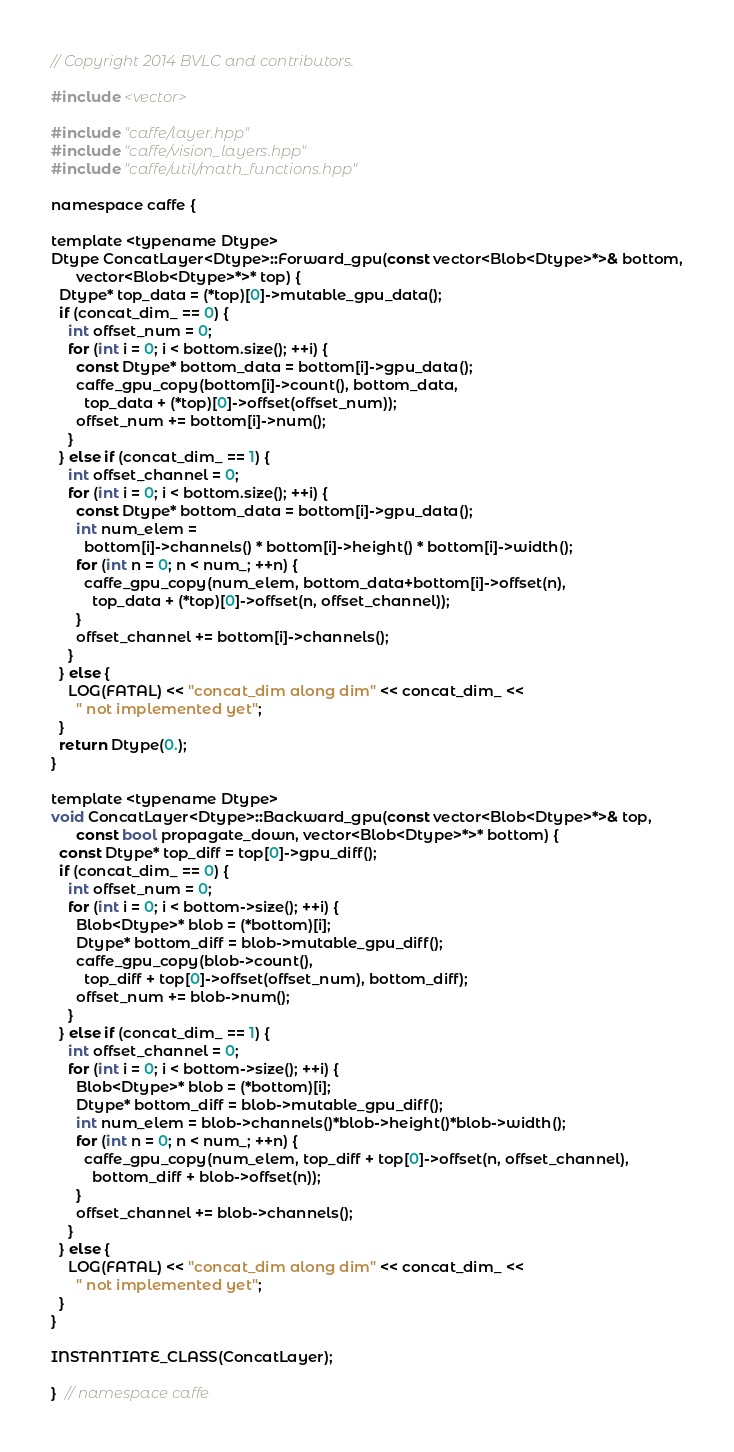Convert code to text. <code><loc_0><loc_0><loc_500><loc_500><_Cuda_>// Copyright 2014 BVLC and contributors.

#include <vector>

#include "caffe/layer.hpp"
#include "caffe/vision_layers.hpp"
#include "caffe/util/math_functions.hpp"

namespace caffe {

template <typename Dtype>
Dtype ConcatLayer<Dtype>::Forward_gpu(const vector<Blob<Dtype>*>& bottom,
      vector<Blob<Dtype>*>* top) {
  Dtype* top_data = (*top)[0]->mutable_gpu_data();
  if (concat_dim_ == 0) {
    int offset_num = 0;
    for (int i = 0; i < bottom.size(); ++i) {
      const Dtype* bottom_data = bottom[i]->gpu_data();
      caffe_gpu_copy(bottom[i]->count(), bottom_data,
        top_data + (*top)[0]->offset(offset_num));
      offset_num += bottom[i]->num();
    }
  } else if (concat_dim_ == 1) {
    int offset_channel = 0;
    for (int i = 0; i < bottom.size(); ++i) {
      const Dtype* bottom_data = bottom[i]->gpu_data();
      int num_elem =
        bottom[i]->channels() * bottom[i]->height() * bottom[i]->width();
      for (int n = 0; n < num_; ++n) {
        caffe_gpu_copy(num_elem, bottom_data+bottom[i]->offset(n),
          top_data + (*top)[0]->offset(n, offset_channel));
      }
      offset_channel += bottom[i]->channels();
    }
  } else {
    LOG(FATAL) << "concat_dim along dim" << concat_dim_ <<
      " not implemented yet";
  }
  return Dtype(0.);
}

template <typename Dtype>
void ConcatLayer<Dtype>::Backward_gpu(const vector<Blob<Dtype>*>& top,
      const bool propagate_down, vector<Blob<Dtype>*>* bottom) {
  const Dtype* top_diff = top[0]->gpu_diff();
  if (concat_dim_ == 0) {
    int offset_num = 0;
    for (int i = 0; i < bottom->size(); ++i) {
      Blob<Dtype>* blob = (*bottom)[i];
      Dtype* bottom_diff = blob->mutable_gpu_diff();
      caffe_gpu_copy(blob->count(),
        top_diff + top[0]->offset(offset_num), bottom_diff);
      offset_num += blob->num();
    }
  } else if (concat_dim_ == 1) {
    int offset_channel = 0;
    for (int i = 0; i < bottom->size(); ++i) {
      Blob<Dtype>* blob = (*bottom)[i];
      Dtype* bottom_diff = blob->mutable_gpu_diff();
      int num_elem = blob->channels()*blob->height()*blob->width();
      for (int n = 0; n < num_; ++n) {
        caffe_gpu_copy(num_elem, top_diff + top[0]->offset(n, offset_channel),
          bottom_diff + blob->offset(n));
      }
      offset_channel += blob->channels();
    }
  } else {
    LOG(FATAL) << "concat_dim along dim" << concat_dim_ <<
      " not implemented yet";
  }
}

INSTANTIATE_CLASS(ConcatLayer);

}  // namespace caffe
</code> 